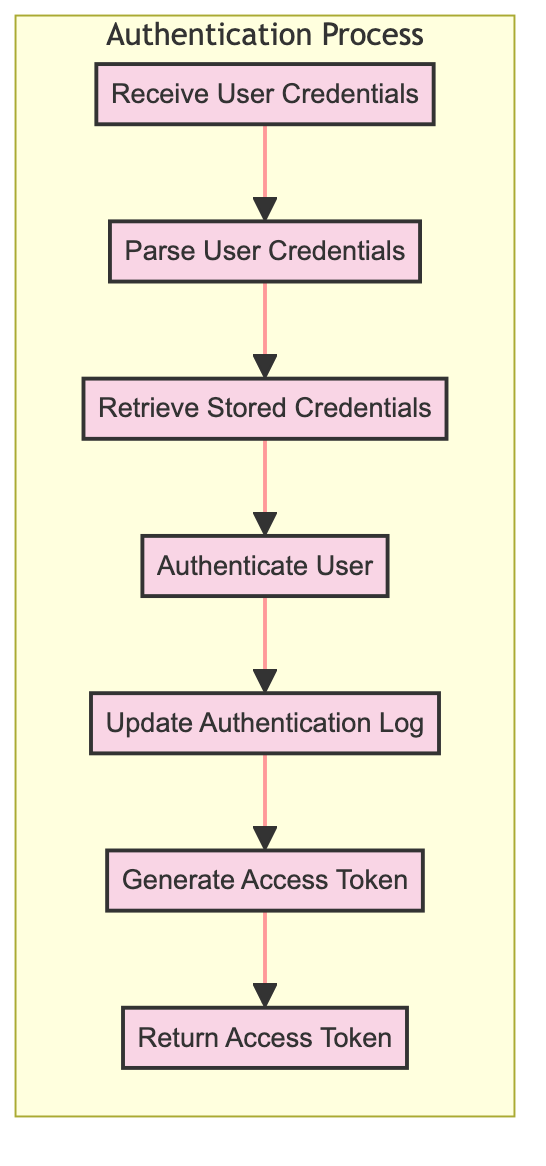What is the first step in the user authentication process? The first step in the user authentication process is "Receive User Credentials," as it is the initial function in the flowchart.
Answer: Receive User Credentials How many functions are there in the authentication process? There are a total of six functions represented in the flowchart that make up the authentication process.
Answer: Six What does the output of the "Authenticate User" function comprise? The "Authenticate User" function outputs an "Authentication Status," which indicates whether the user's credentials are valid.
Answer: Authentication Status Which function follows "Update Authentication Log"? "Generate Access Token" follows "Update Authentication Log" in the flowchart, indicating that it comes after the logging process.
Answer: Generate Access Token What is the final output of the entire user authentication process? The final output of the process is "Access Token," which is provided to the user upon the completion of all previous functions successfully.
Answer: Access Token What input does "Generate Access Token" require? "Generate Access Token" requires two inputs: "User ID" and "Time Stamp," which are necessary for generating the access token securely.
Answer: User ID, Time Stamp Why is "Parse User Credentials" important in this process? "Parse User Credentials" is important because it extracts the essential components needed for authentication, specifically the User ID and Password from the provided credentials.
Answer: It extracts User ID and Password What is logged by the "Update Authentication Log" function? The "Update Authentication Log" function logs the authentication attempt including User ID, Timestamp, and Authentication Result to maintain a record of the attempts.
Answer: Authentication attempt details Which function produces the access token? "Generate Access Token" produces the access token after successful user authentication, marking a critical step in the process.
Answer: Generate Access Token 